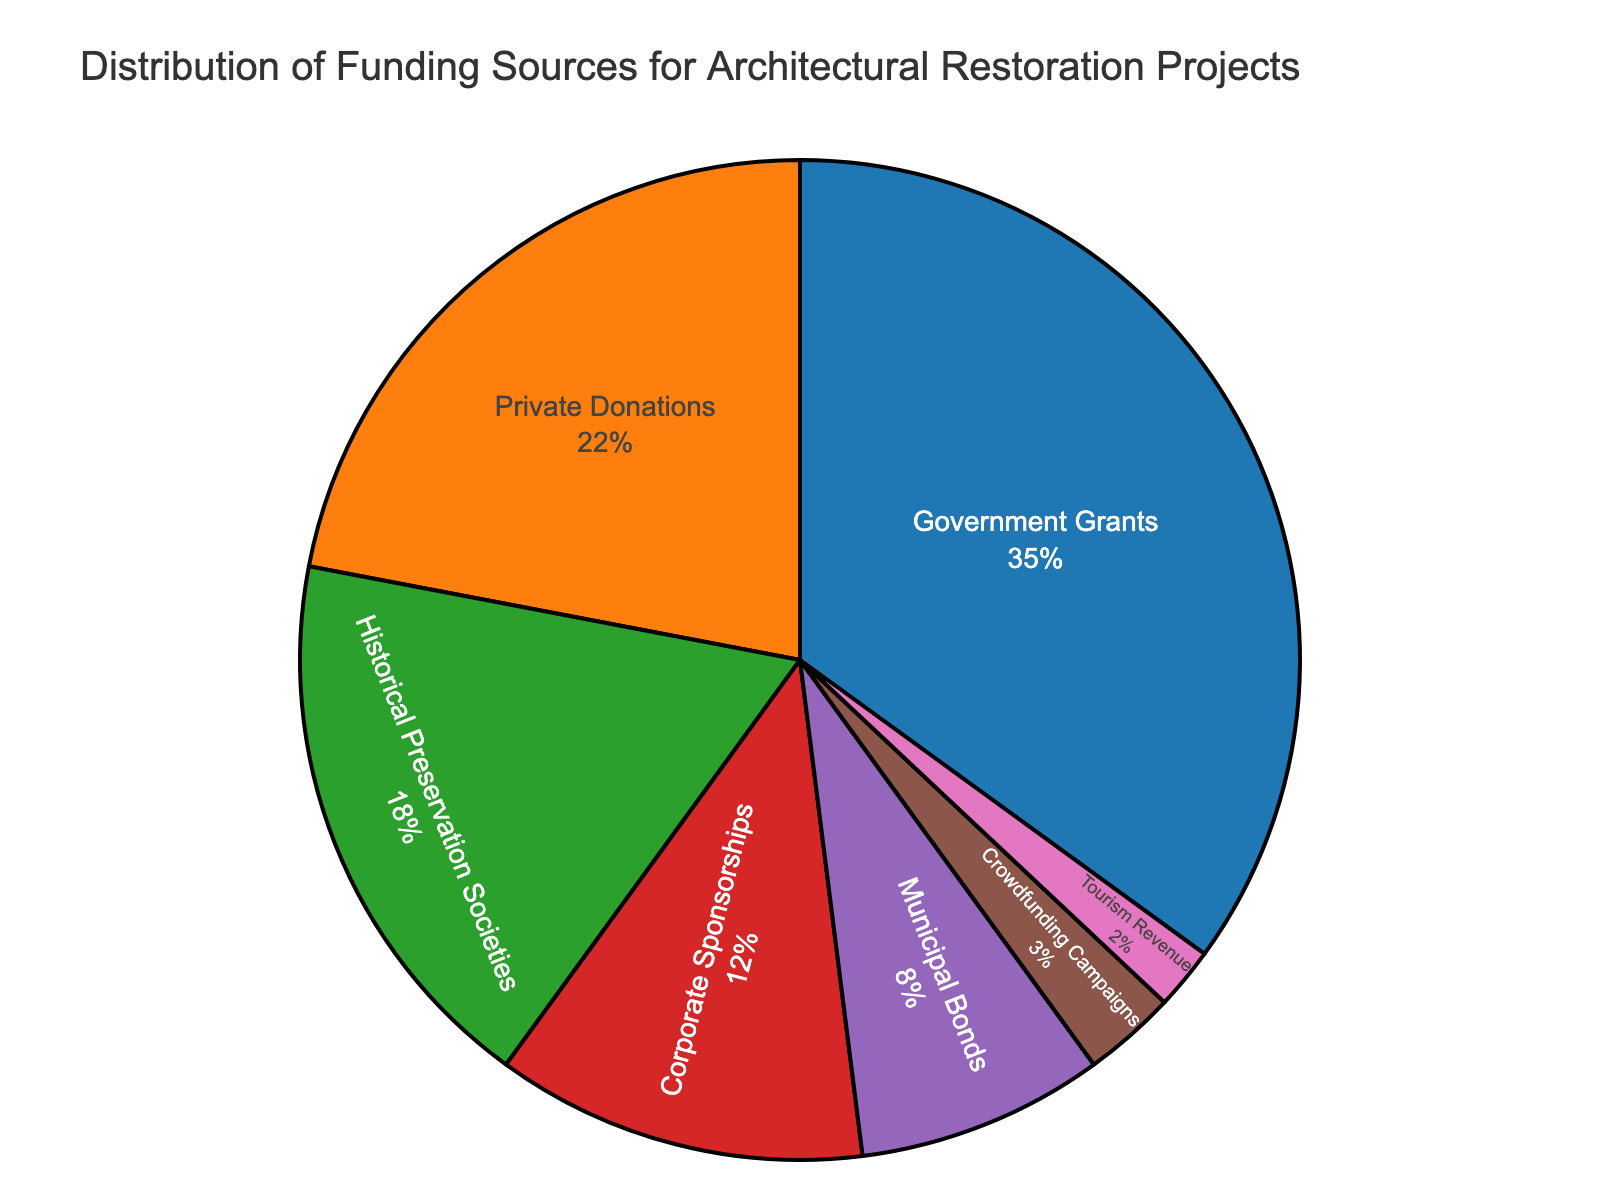What percentage of funding comes from private sources (i.e., Private Donations, Corporate Sponsorships, Crowdfunding Campaigns, and Tourism Revenue)? Add the percentages of Private Donations (22%), Corporate Sponsorships (12%), Crowdfunding Campaigns (3%), and Tourism Revenue (2%). 22% + 12% + 3% + 2% = 39%
Answer: 39% Which funding source contributes more, Government Grants or Historical Preservation Societies? Compare the percentages of Government Grants (35%) and Historical Preservation Societies (18%). 35% is greater than 18%, so Government Grants contribute more.
Answer: Government Grants Which type of funding source has the smallest contribution, and what is its percentage? Identify the funding source with the lowest percentage in the chart. Crowdfunding Campaigns has the smallest contribution with 3%.
Answer: Crowdfunding Campaigns, 3% If a project requires $1,000,000 in total funding, how much would be expected from Municipal Bonds based on the percentage distribution? Calculate the 8% of $1,000,000 required for the project from Municipal Bonds. 0.08 * $1,000,000 = $80,000
Answer: $80,000 What is the combined percentage of Corporate Sponsorships and Private Donations? Add the percentages of Corporate Sponsorships (12%) and Private Donations (22%). 12% + 22% = 34%
Answer: 34% How does the percentage of funding from Municipal Bonds compare to that from Crowdfunding Campaigns? Compare the percentages of Municipal Bonds (8%) and Crowdfunding Campaigns (3%). 8% is greater than 3%, so Municipal Bonds contribute more.
Answer: Municipal Bonds contribute more What is the difference in percentage between Private Donations and Corporate Sponsorships? Subtract the percentage of Corporate Sponsorships (12%) from the percentage of Private Donations (22%). 22% - 12% = 10%
Answer: 10% Which funding source, other than Government Grants, has the highest contribution, and what is the percentage? Identify the highest contribution after Government Grants (35%). Private Donations have the next highest percentage at 22%.
Answer: Private Donations, 22% What percentage of funding comes from sources other than Government Grants and Private Donations? Subtract the combined percentage of Government Grants (35%) and Private Donations (22%) from 100%. 100% - (35% + 22%) = 43%
Answer: 43% If the total funding is $2,500,000, how much is contributed by Historical Preservation Societies and Tourism Revenue combined? Calculate the amount based on their combined percentage. (18% + 2%) of $2,500,000. 0.20 * $2,500,000 = $500,000
Answer: $500,000 